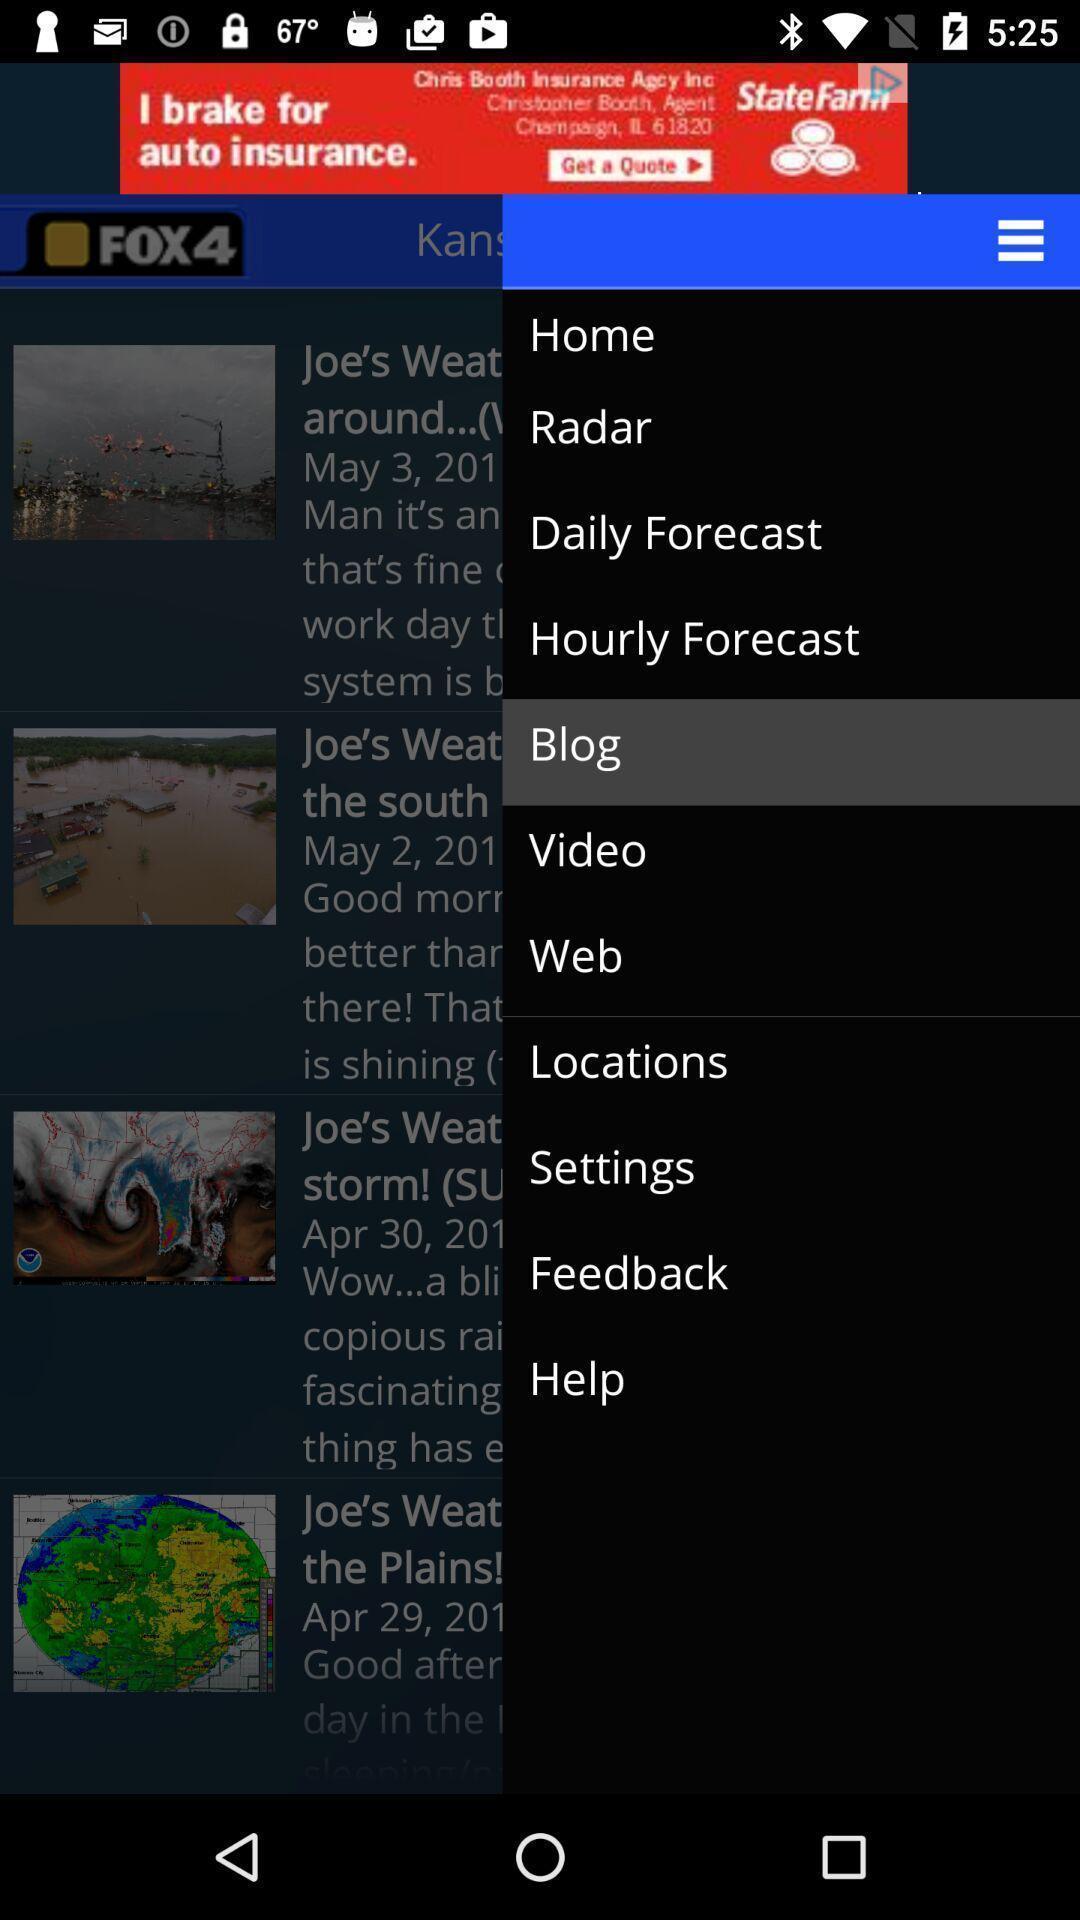What details can you identify in this image? Popup showing few options in a weather app. 